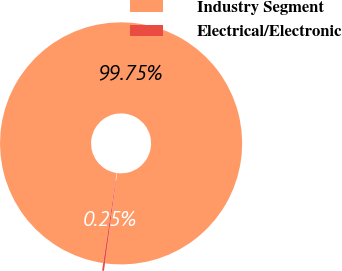Convert chart. <chart><loc_0><loc_0><loc_500><loc_500><pie_chart><fcel>Industry Segment<fcel>Electrical/Electronic<nl><fcel>99.75%<fcel>0.25%<nl></chart> 